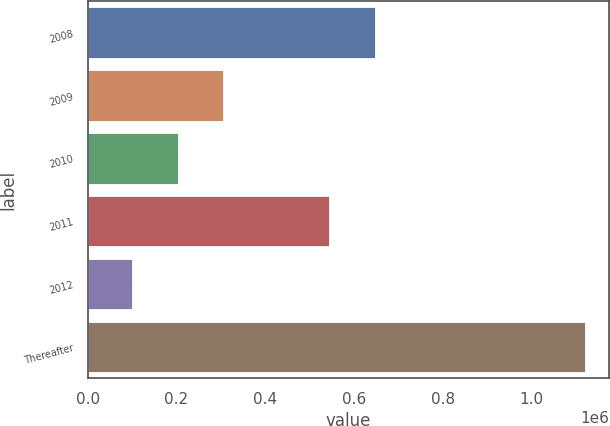Convert chart to OTSL. <chart><loc_0><loc_0><loc_500><loc_500><bar_chart><fcel>2008<fcel>2009<fcel>2010<fcel>2011<fcel>2012<fcel>Thereafter<nl><fcel>646621<fcel>304259<fcel>202326<fcel>544688<fcel>100393<fcel>1.11972e+06<nl></chart> 